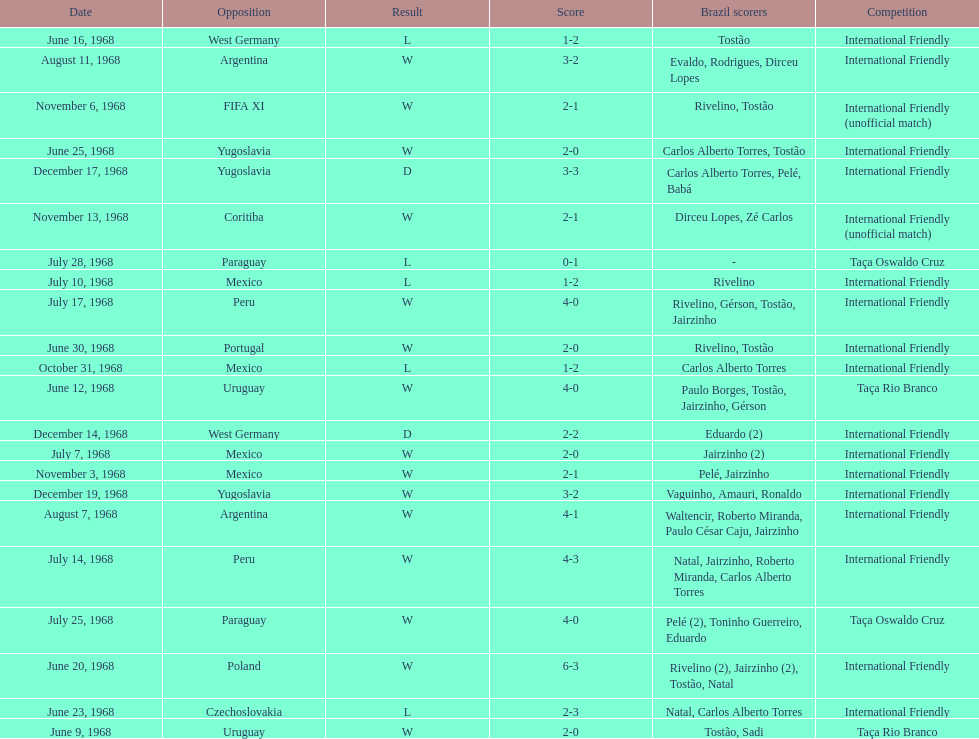How many times did brazil score during the game on november 6th? 2. 